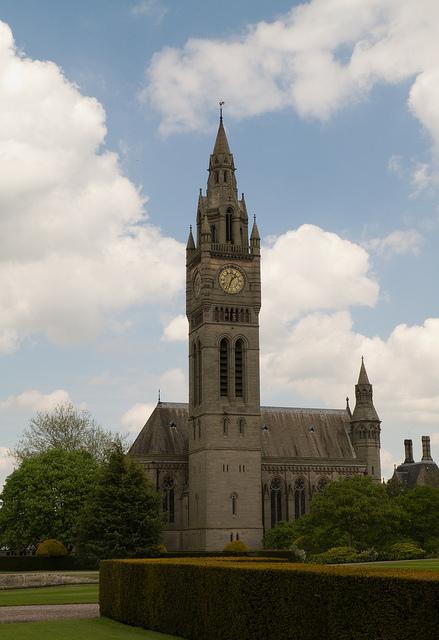Are there any clouds in the sky?
Keep it brief. Yes. What number is the small hand on the clock pointing to?
Be succinct. 1. What time does the clock show?
Keep it brief. 2:35. What time of day is this?
Short answer required. Afternoon. What time is it?
Keep it brief. 1:35. What type of building is this?
Quick response, please. Church. 